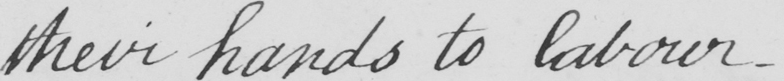What is written in this line of handwriting? their hands to labour. 